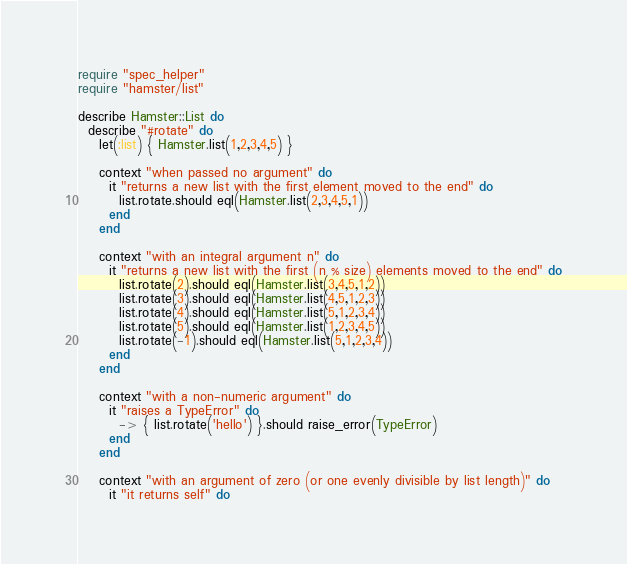<code> <loc_0><loc_0><loc_500><loc_500><_Ruby_>require "spec_helper"
require "hamster/list"

describe Hamster::List do
  describe "#rotate" do
    let(:list) { Hamster.list(1,2,3,4,5) }

    context "when passed no argument" do
      it "returns a new list with the first element moved to the end" do
        list.rotate.should eql(Hamster.list(2,3,4,5,1))
      end
    end

    context "with an integral argument n" do
      it "returns a new list with the first (n % size) elements moved to the end" do
        list.rotate(2).should eql(Hamster.list(3,4,5,1,2))
        list.rotate(3).should eql(Hamster.list(4,5,1,2,3))
        list.rotate(4).should eql(Hamster.list(5,1,2,3,4))
        list.rotate(5).should eql(Hamster.list(1,2,3,4,5))
        list.rotate(-1).should eql(Hamster.list(5,1,2,3,4))
      end
    end

    context "with a non-numeric argument" do
      it "raises a TypeError" do
        -> { list.rotate('hello') }.should raise_error(TypeError)
      end
    end

    context "with an argument of zero (or one evenly divisible by list length)" do
      it "it returns self" do</code> 